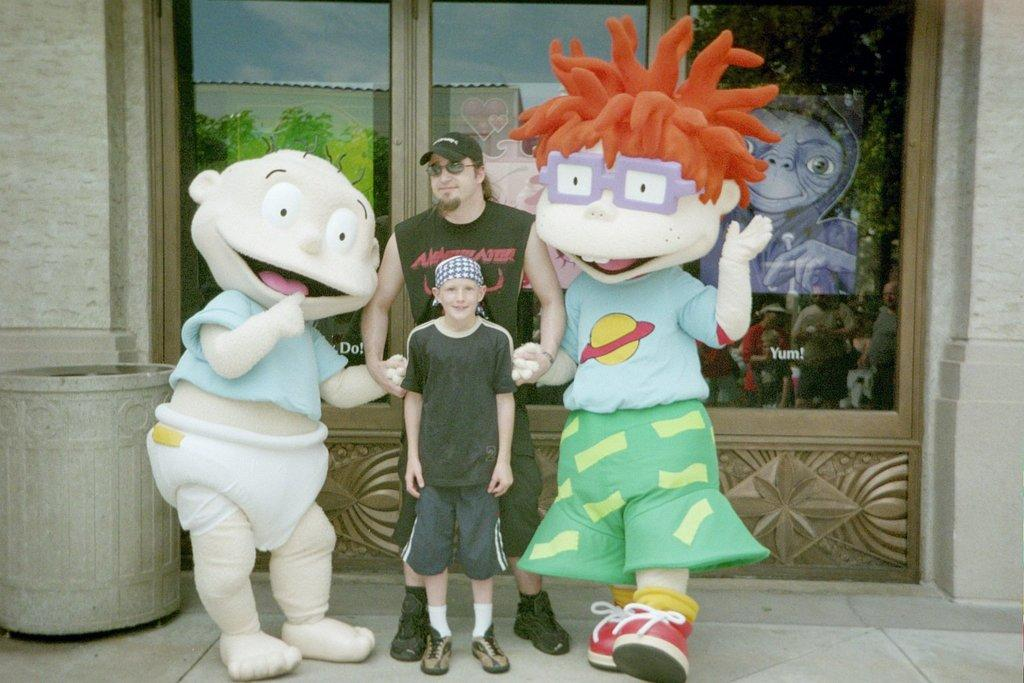How many people are present in the image? There are two persons in the image. What else can be seen in the image besides the two people? There are mascots in the image. What is visible in the background of the image? There is a wall, a bin, and glasses in the background of the image. Can you describe the reflection on the glasses? The reflection on the glasses shows a poster, the sky, and a few persons. What type of holiday is being celebrated in the image? There is no indication of a holiday being celebrated in the image. What game are the two persons playing in the image? There is no game being played in the image; the two persons are simply present. 